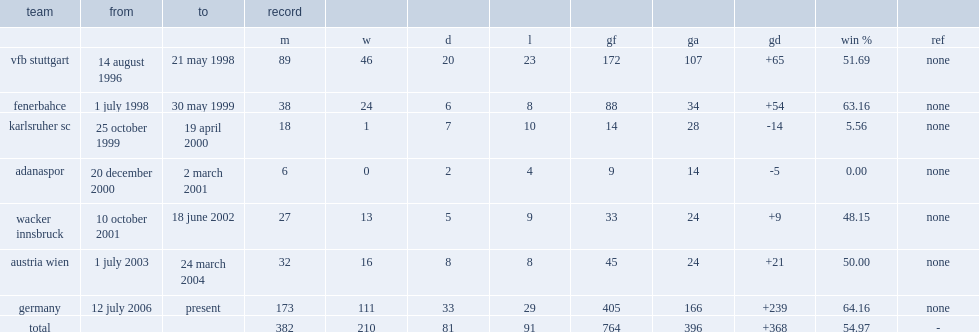When did joachim low play for austria wien. 1 july 2003. 